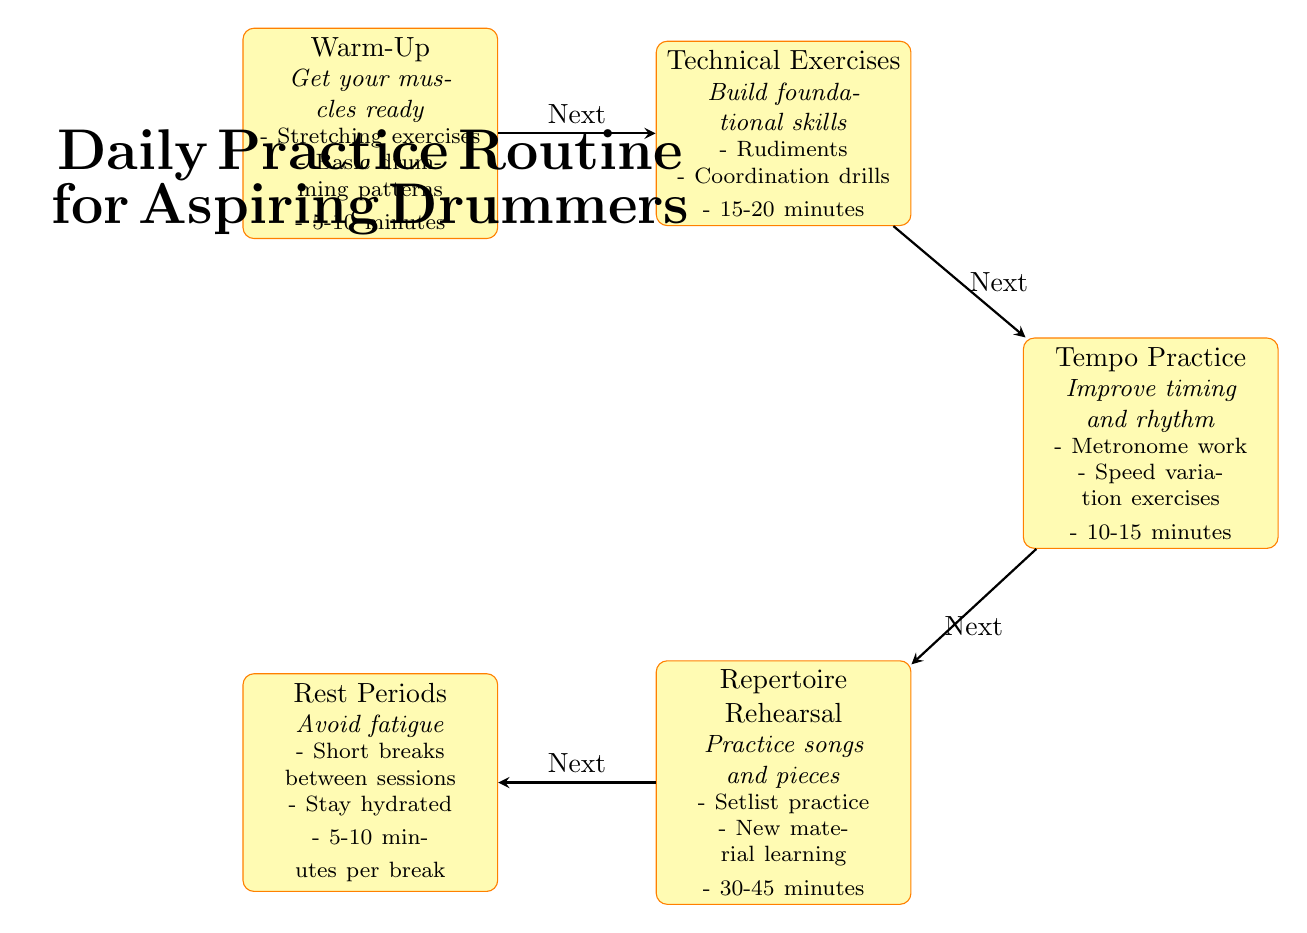What is the first step in the practice routine? The diagram shows that the first step is "Warm-Up", which is the first node in the flow of the practice routine.
Answer: Warm-Up How long should technical exercises take? The diagram indicates that "Technical Exercises" should last between 15-20 minutes, as specified in the footnote of the technical exercises node.
Answer: 15-20 minutes What is included in rest periods? The diagram states that rest periods include "Short breaks between sessions", "Stay hydrated", and "5-10 minutes per break", outlining what a drummer should do during this time.
Answer: Short breaks between sessions, Stay hydrated, 5-10 minutes per break Which exercise comes after tempo practice? According to the arrows in the diagram, "Repertoire Rehearsal" directly follows "Tempo Practice," indicating the order of exercises in the routine.
Answer: Repertoire Rehearsal What is the total time spent on repertoire rehearsal? The diagram shows that "Repertoire Rehearsal" lasts 30-45 minutes as noted in its details, giving the total time duration for this step.
Answer: 30-45 minutes How do rest periods affect practice? The diagram states that rest periods are for "Avoid fatigue", emphasizing the importance of breaks in maintaining a drummer’s performance quality throughout their practice.
Answer: Avoid fatigue How many main exercises are outlined in the diagram? The diagram clearly lists five main nodes: Warm-Up, Technical Exercises, Tempo Practice, Repertoire Rehearsal, and Rest Periods, which gives the total number of exercises included in the routine.
Answer: Five What flow connects the warm-up to the rest periods? The arrows in the diagram represent the flow connecting each practice step, indicating that after completing the warm-up, the next step is technical exercises, progressing to tempo practice, then repertoire rehearsal, and finally leading to rest periods.
Answer: Warm-Up to Technical Exercises to Tempo Practice to Repertoire Rehearsal to Rest Periods 